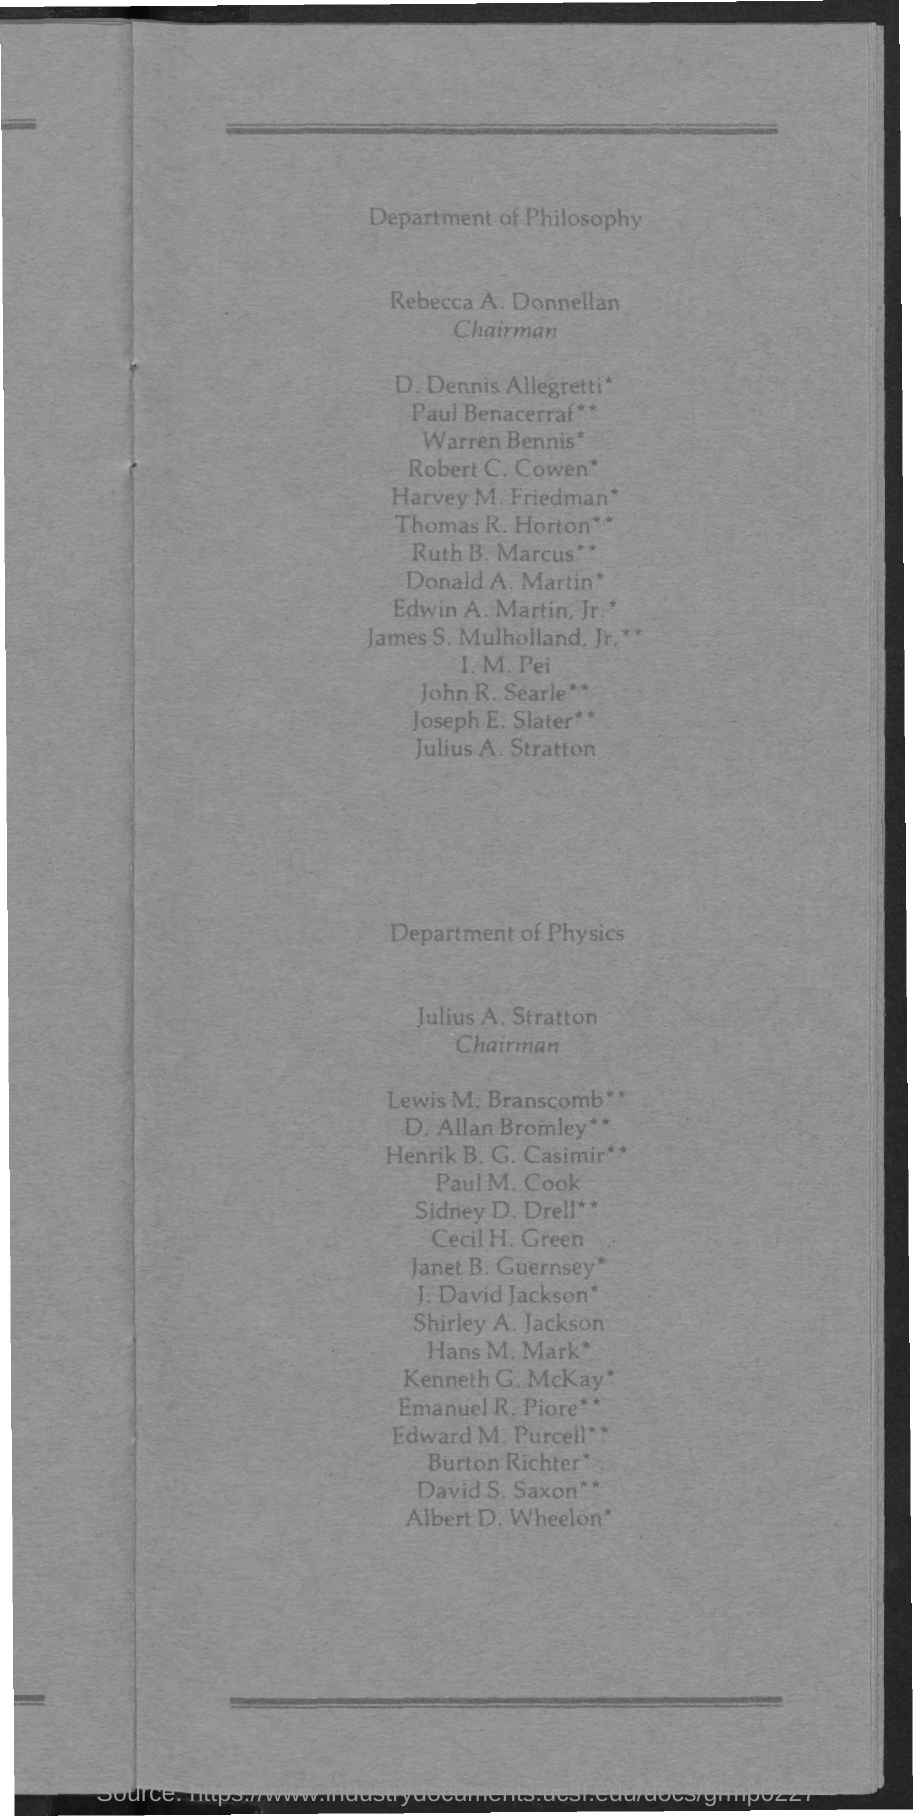Draw attention to some important aspects in this diagram. The Chairman of the Department of Philosophy is Rebecca A. Donnellan. Julius A. Stratton is the Chairman of the Department of Physics. 